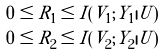Convert formula to latex. <formula><loc_0><loc_0><loc_500><loc_500>0 \leq R _ { 1 } & \leq I ( V _ { 1 } ; Y _ { 1 } | U ) \\ 0 \leq R _ { 2 } & \leq I ( V _ { 2 } ; Y _ { 2 } | U )</formula> 